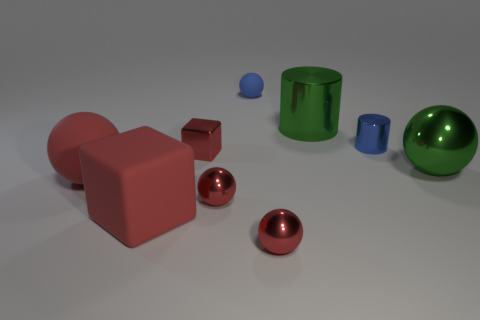Subtract all tiny matte balls. How many balls are left? 4 Subtract all green spheres. How many spheres are left? 4 Subtract all cubes. How many objects are left? 7 Subtract 5 balls. How many balls are left? 0 Subtract all brown blocks. Subtract all red cylinders. How many blocks are left? 2 Subtract all green blocks. How many green balls are left? 1 Subtract all large cyan metallic things. Subtract all tiny blue shiny objects. How many objects are left? 8 Add 2 cylinders. How many cylinders are left? 4 Add 5 small metal cylinders. How many small metal cylinders exist? 6 Subtract 0 red cylinders. How many objects are left? 9 